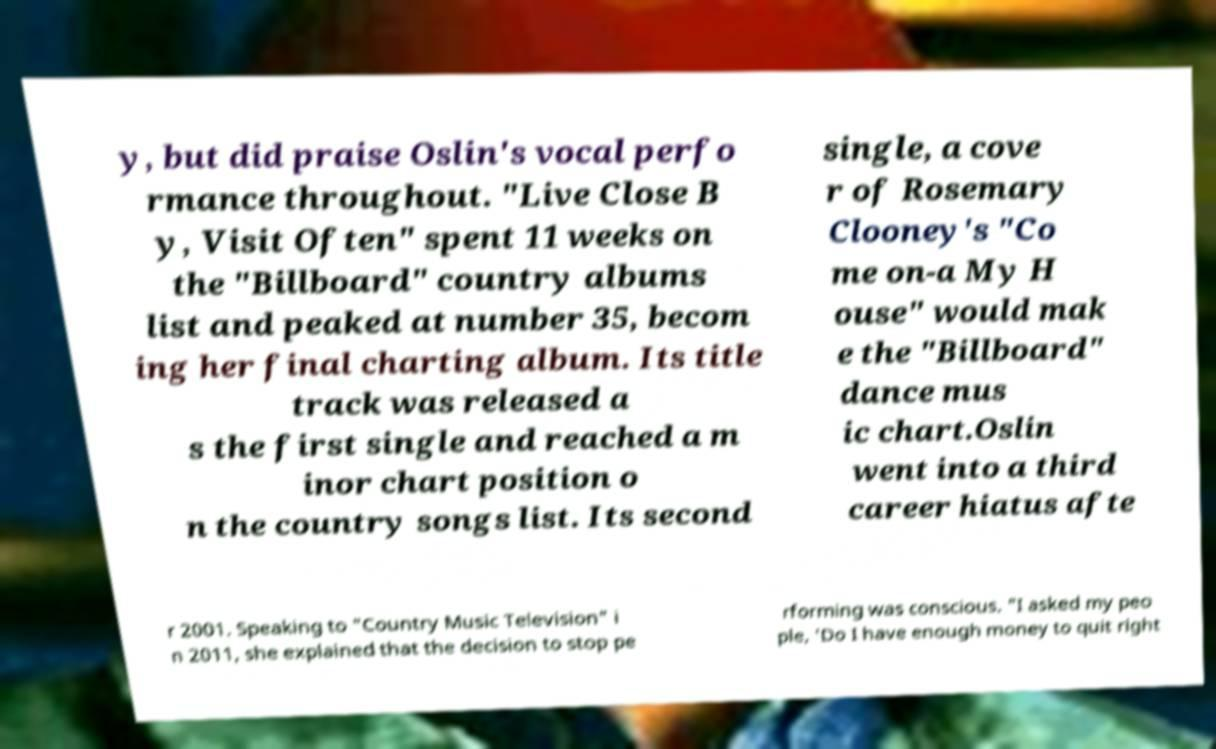For documentation purposes, I need the text within this image transcribed. Could you provide that? y, but did praise Oslin's vocal perfo rmance throughout. "Live Close B y, Visit Often" spent 11 weeks on the "Billboard" country albums list and peaked at number 35, becom ing her final charting album. Its title track was released a s the first single and reached a m inor chart position o n the country songs list. Its second single, a cove r of Rosemary Clooney's "Co me on-a My H ouse" would mak e the "Billboard" dance mus ic chart.Oslin went into a third career hiatus afte r 2001. Speaking to "Country Music Television" i n 2011, she explained that the decision to stop pe rforming was conscious. "I asked my peo ple, 'Do I have enough money to quit right 